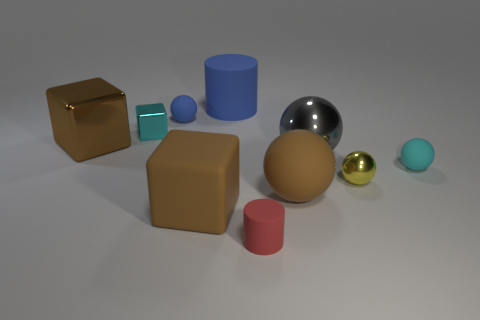How big is the brown object to the left of the tiny metallic object that is to the left of the yellow shiny thing?
Keep it short and to the point. Large. There is a small object that is left of the tiny yellow metallic sphere and in front of the big brown metallic thing; what material is it?
Make the answer very short. Rubber. There is a gray ball; is it the same size as the brown metallic block that is on the left side of the tiny cyan rubber sphere?
Give a very brief answer. Yes. Is there a big brown block?
Your answer should be very brief. Yes. There is a cyan object that is the same shape as the big gray object; what is it made of?
Give a very brief answer. Rubber. What size is the rubber sphere in front of the small ball in front of the small rubber sphere to the right of the red cylinder?
Keep it short and to the point. Large. There is a small yellow sphere; are there any cyan things on the left side of it?
Your answer should be very brief. Yes. The brown block that is the same material as the red cylinder is what size?
Offer a terse response. Large. How many purple things are the same shape as the big blue matte object?
Make the answer very short. 0. Is the material of the big blue cylinder the same as the cube that is in front of the big gray ball?
Provide a succinct answer. Yes. 